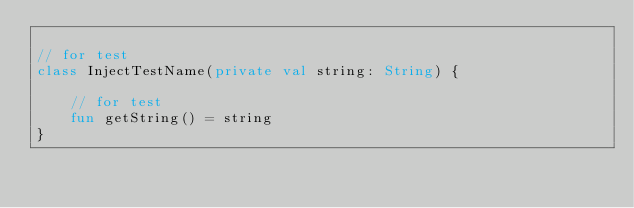Convert code to text. <code><loc_0><loc_0><loc_500><loc_500><_Kotlin_>
// for test
class InjectTestName(private val string: String) {

    // for test
    fun getString() = string
}</code> 